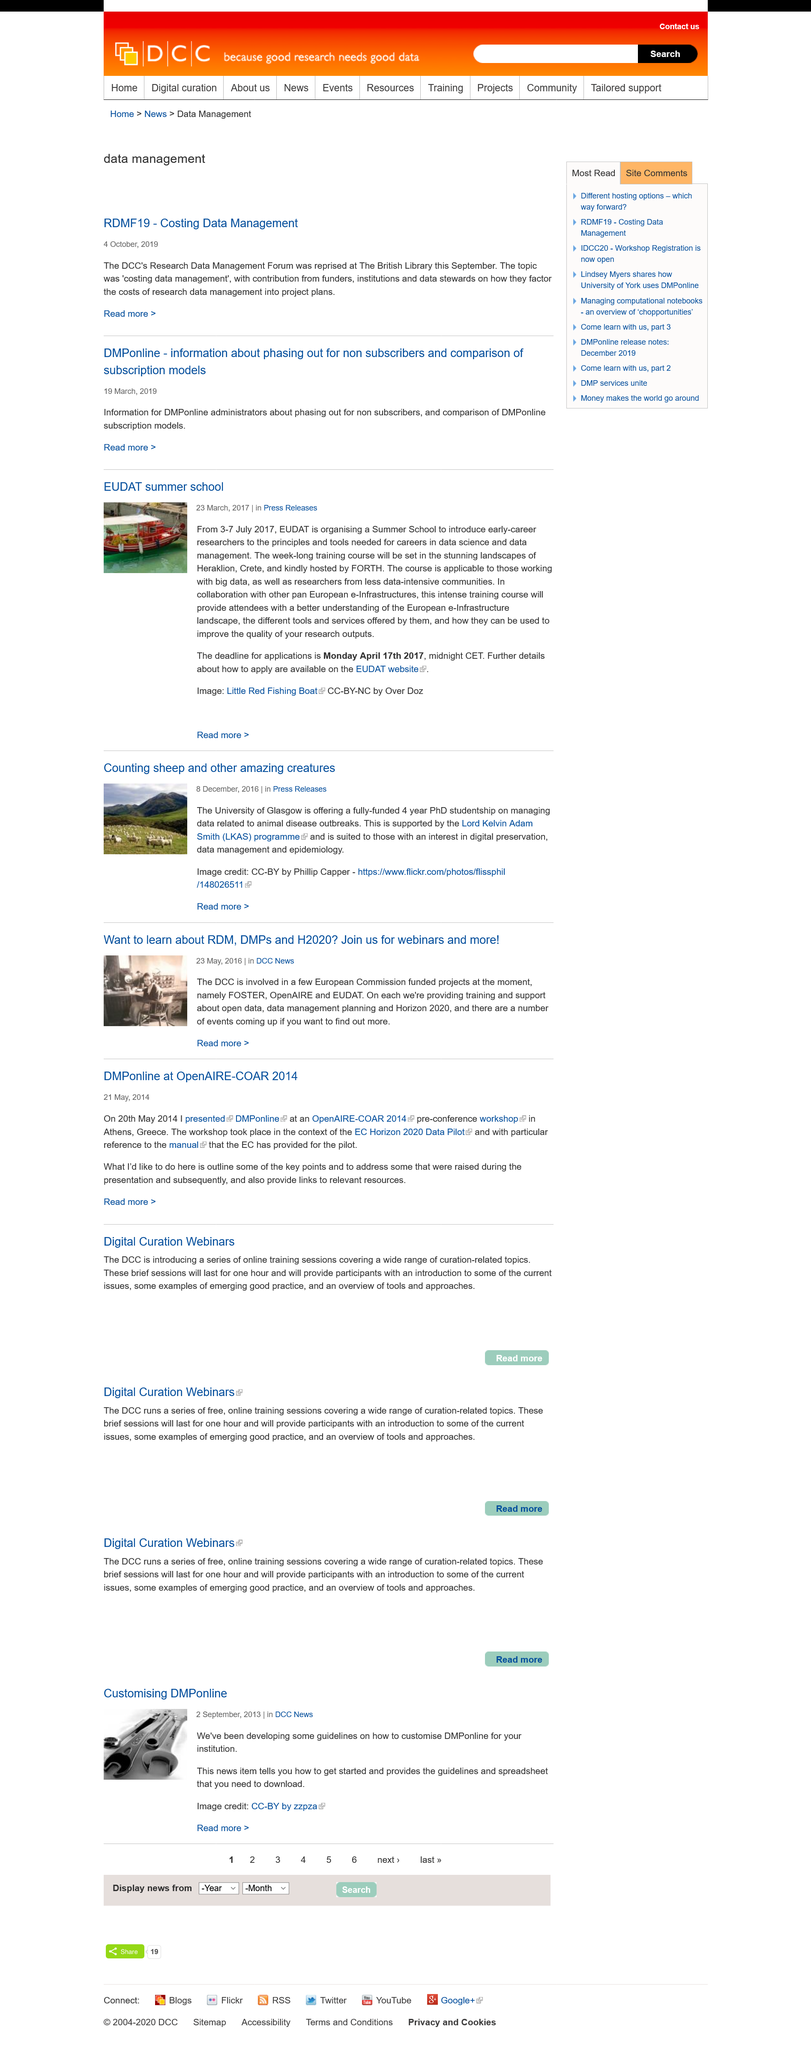Point out several critical features in this image. The details of the EUDAT summer school can be found on the EUDAT website. The Digital Curation Coalition is introducing a series of online training sessions that cover a diverse range of curation-related subjects. As of May 23, 2016, the DCC was involved with three European Commission funded projects: FOSTER, OpenAIRE, and EUDAT. The presentation of DMPonline by the author took place at the OpenAIRE-COAR 2014 conference on May 20, 2014. The University of Glasgow is offering a fully-funded four-year PhD studentship on managing data related to animal disease outbreaks. 